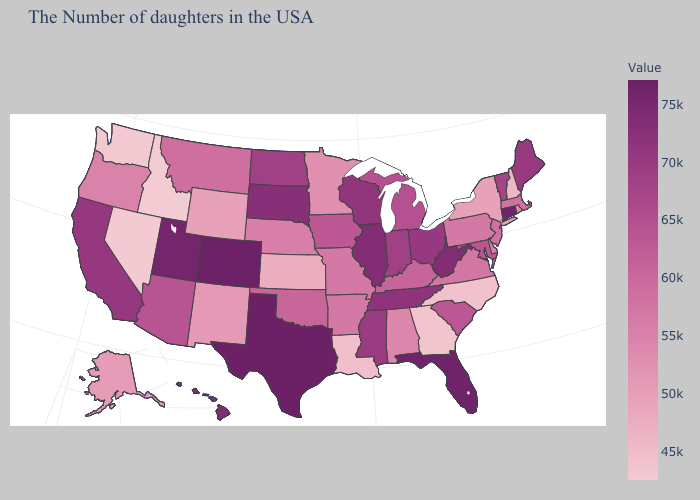Does Utah have a lower value than Kentucky?
Quick response, please. No. Among the states that border Illinois , does Wisconsin have the highest value?
Short answer required. Yes. Is the legend a continuous bar?
Be succinct. Yes. Which states have the lowest value in the West?
Be succinct. Idaho. Does West Virginia have a lower value than Idaho?
Quick response, please. No. Among the states that border Oklahoma , does Kansas have the lowest value?
Keep it brief. Yes. Which states have the highest value in the USA?
Short answer required. Texas. Among the states that border Wyoming , which have the lowest value?
Answer briefly. Idaho. 